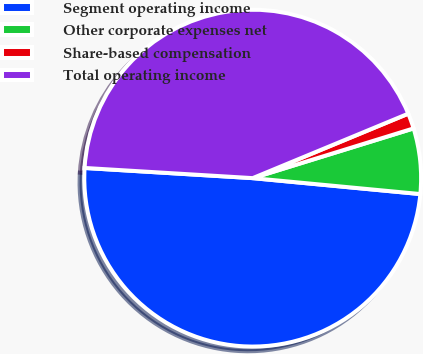<chart> <loc_0><loc_0><loc_500><loc_500><pie_chart><fcel>Segment operating income<fcel>Other corporate expenses net<fcel>Share-based compensation<fcel>Total operating income<nl><fcel>49.46%<fcel>6.28%<fcel>1.48%<fcel>42.79%<nl></chart> 